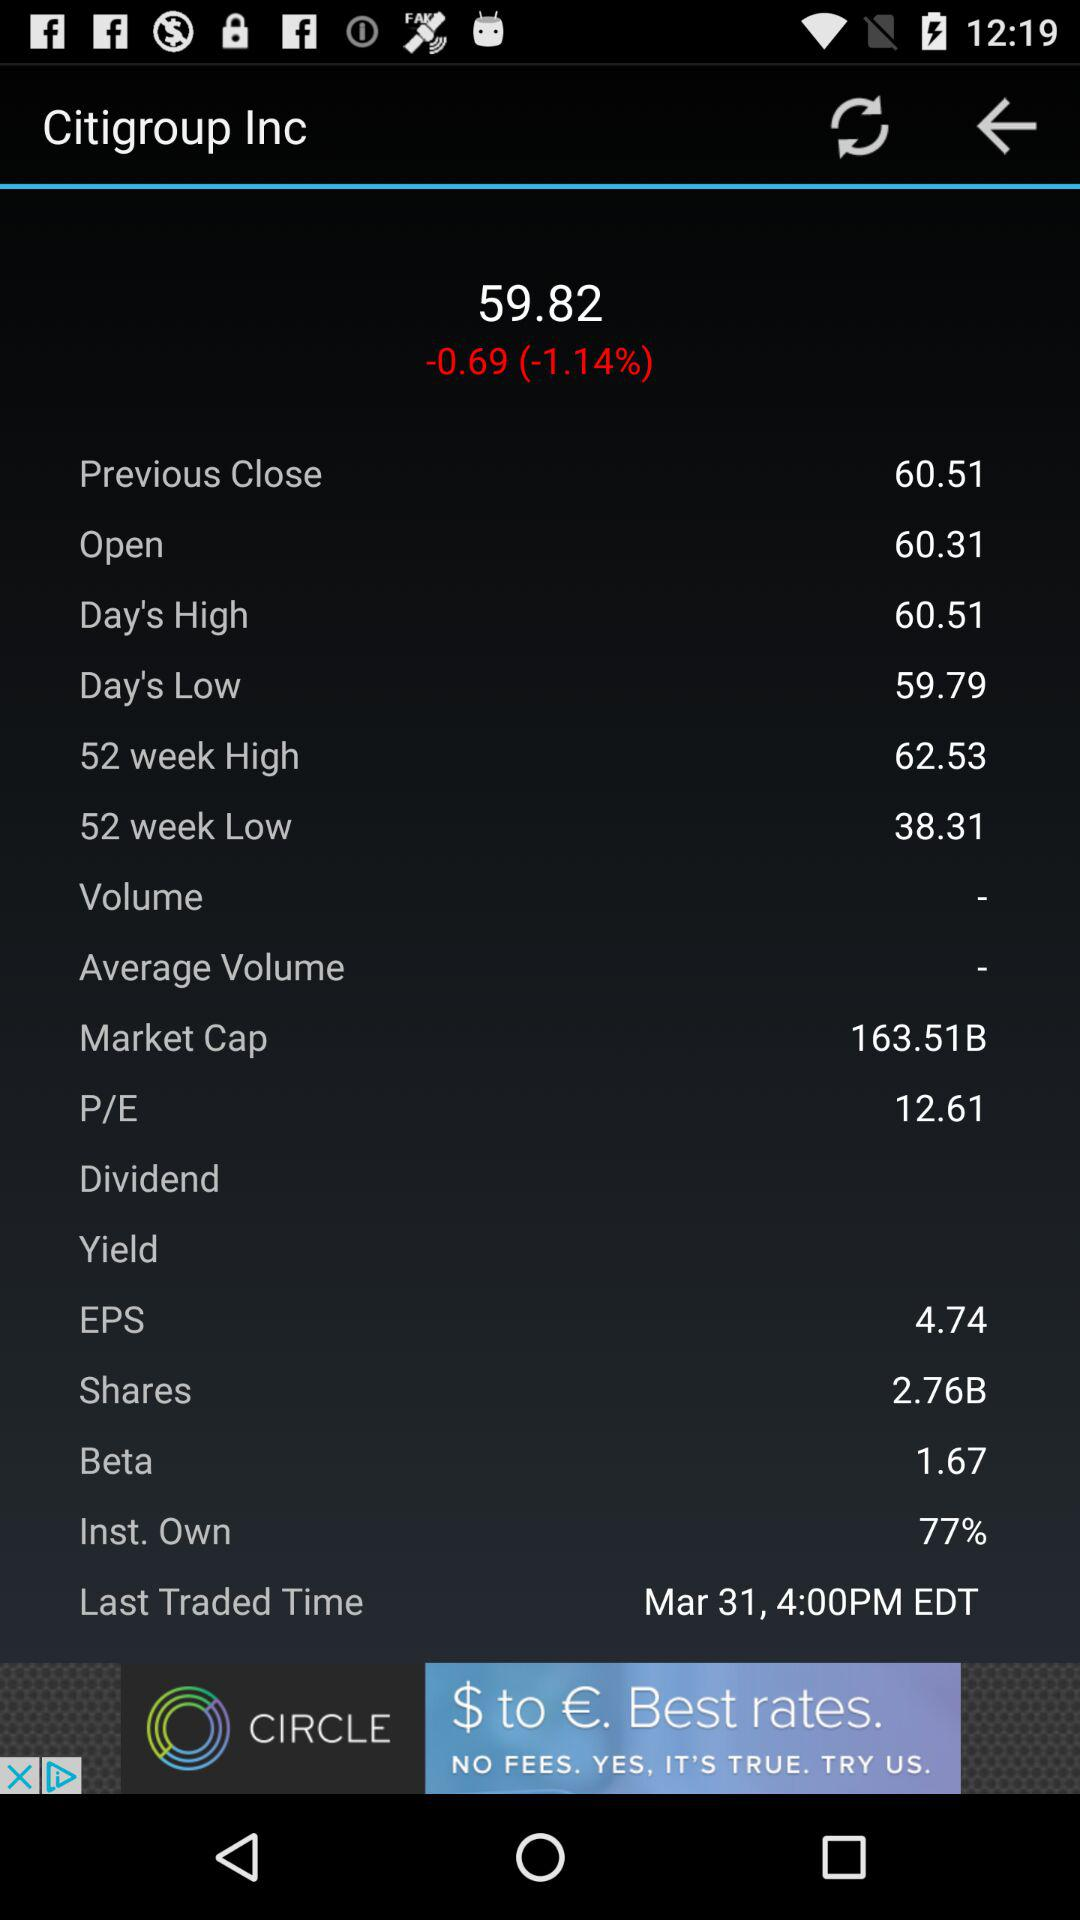What is the percentage change from the previous close?
Answer the question using a single word or phrase. -1.14% 